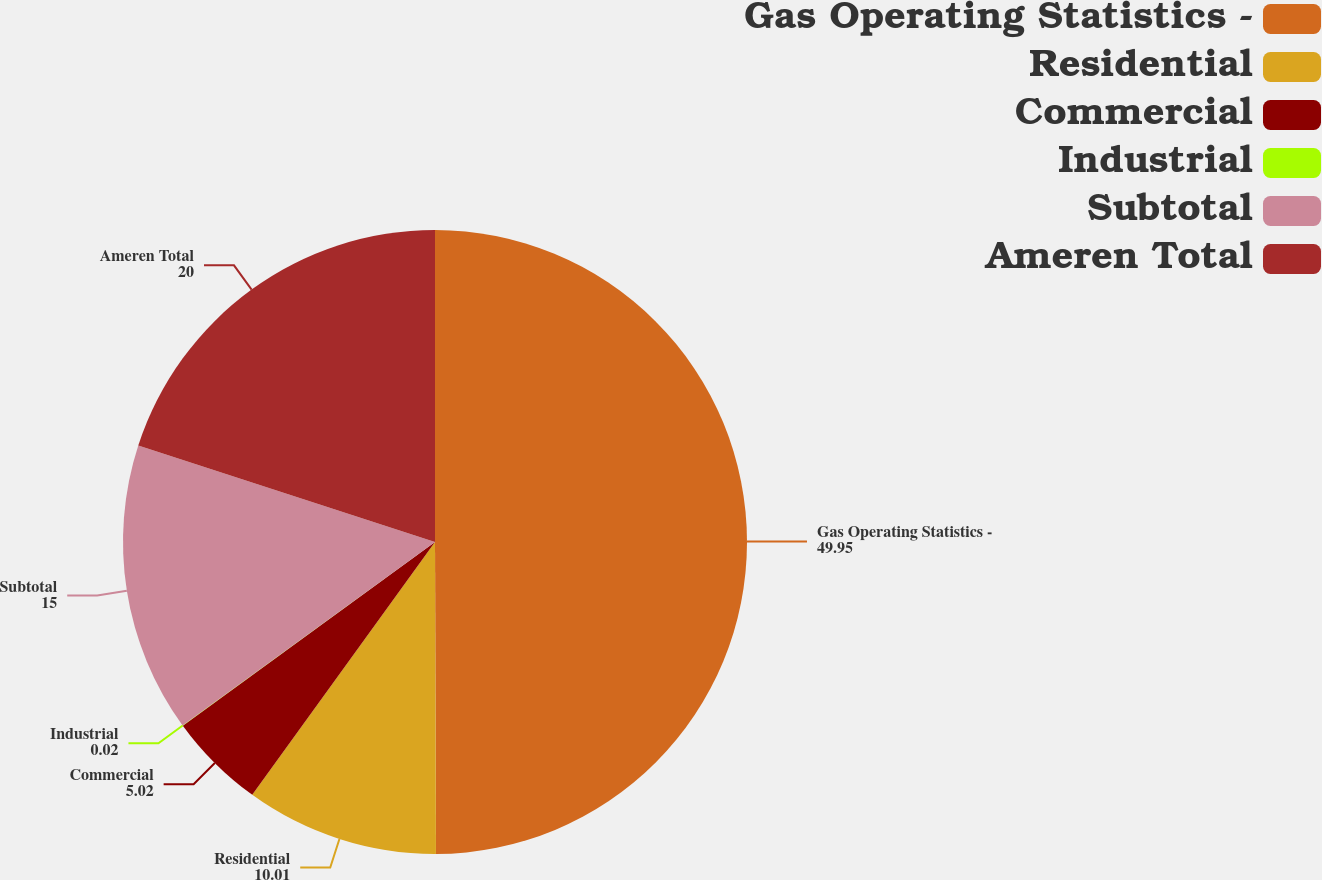<chart> <loc_0><loc_0><loc_500><loc_500><pie_chart><fcel>Gas Operating Statistics -<fcel>Residential<fcel>Commercial<fcel>Industrial<fcel>Subtotal<fcel>Ameren Total<nl><fcel>49.95%<fcel>10.01%<fcel>5.02%<fcel>0.02%<fcel>15.0%<fcel>20.0%<nl></chart> 